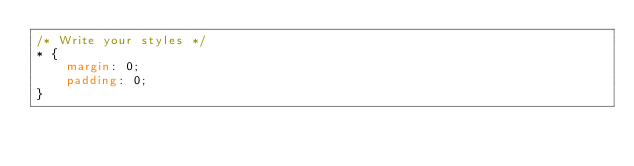Convert code to text. <code><loc_0><loc_0><loc_500><loc_500><_CSS_>/* Write your styles */
* {
    margin: 0;
    padding: 0;
}</code> 